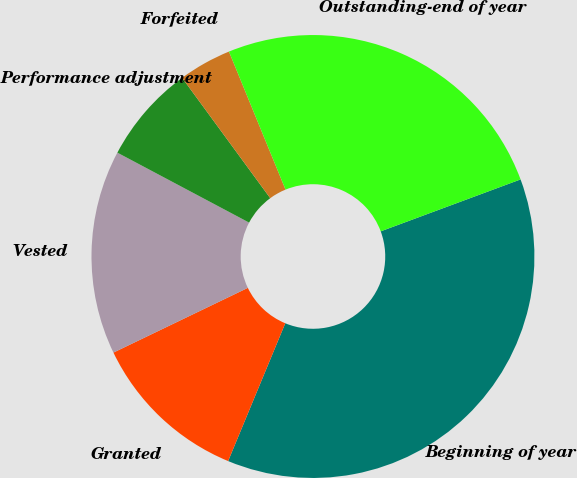<chart> <loc_0><loc_0><loc_500><loc_500><pie_chart><fcel>Beginning of year<fcel>Granted<fcel>Vested<fcel>Performance adjustment<fcel>Forfeited<fcel>Outstanding-end of year<nl><fcel>36.91%<fcel>11.6%<fcel>14.91%<fcel>7.17%<fcel>3.87%<fcel>25.53%<nl></chart> 